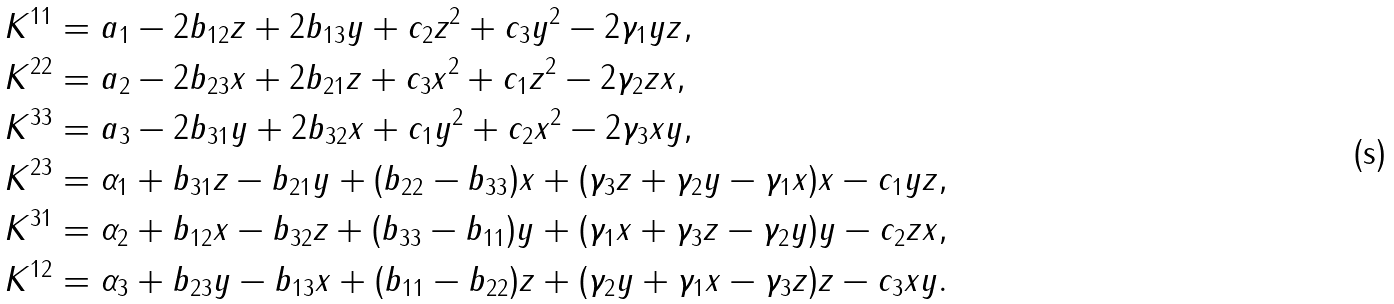<formula> <loc_0><loc_0><loc_500><loc_500>K ^ { 1 1 } & = a _ { 1 } - 2 b _ { 1 2 } z + 2 b _ { 1 3 } y + c _ { 2 } z ^ { 2 } + c _ { 3 } y ^ { 2 } - 2 \gamma _ { 1 } y z , \\ K ^ { 2 2 } & = a _ { 2 } - 2 b _ { 2 3 } x + 2 b _ { 2 1 } z + c _ { 3 } x ^ { 2 } + c _ { 1 } z ^ { 2 } - 2 \gamma _ { 2 } z x , \\ K ^ { 3 3 } & = a _ { 3 } - 2 b _ { 3 1 } y + 2 b _ { 3 2 } x + c _ { 1 } y ^ { 2 } + c _ { 2 } x ^ { 2 } - 2 \gamma _ { 3 } x y , \\ K ^ { 2 3 } & = \alpha _ { 1 } + b _ { 3 1 } z - b _ { 2 1 } y + ( b _ { 2 2 } - b _ { 3 3 } ) x + ( \gamma _ { 3 } z + \gamma _ { 2 } y - \gamma _ { 1 } x ) x - c _ { 1 } y z , \\ K ^ { 3 1 } & = \alpha _ { 2 } + b _ { 1 2 } x - b _ { 3 2 } z + ( b _ { 3 3 } - b _ { 1 1 } ) y + ( \gamma _ { 1 } x + \gamma _ { 3 } z - \gamma _ { 2 } y ) y - c _ { 2 } z x , \\ K ^ { 1 2 } & = \alpha _ { 3 } + b _ { 2 3 } y - b _ { 1 3 } x + ( b _ { 1 1 } - b _ { 2 2 } ) z + ( \gamma _ { 2 } y + \gamma _ { 1 } x - \gamma _ { 3 } z ) z - c _ { 3 } x y .</formula> 